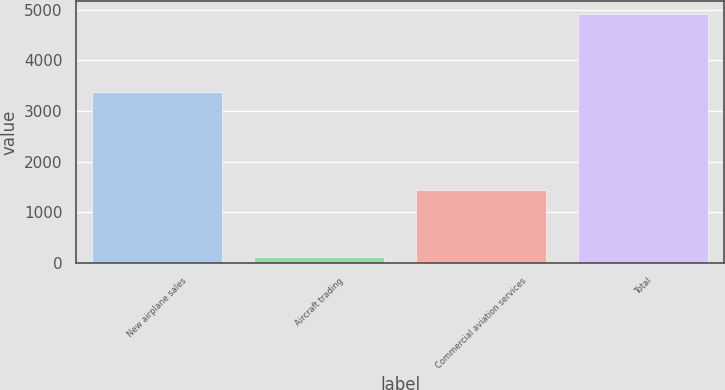Convert chart. <chart><loc_0><loc_0><loc_500><loc_500><bar_chart><fcel>New airplane sales<fcel>Aircraft trading<fcel>Commercial aviation services<fcel>Total<nl><fcel>3369<fcel>120<fcel>1432<fcel>4921<nl></chart> 